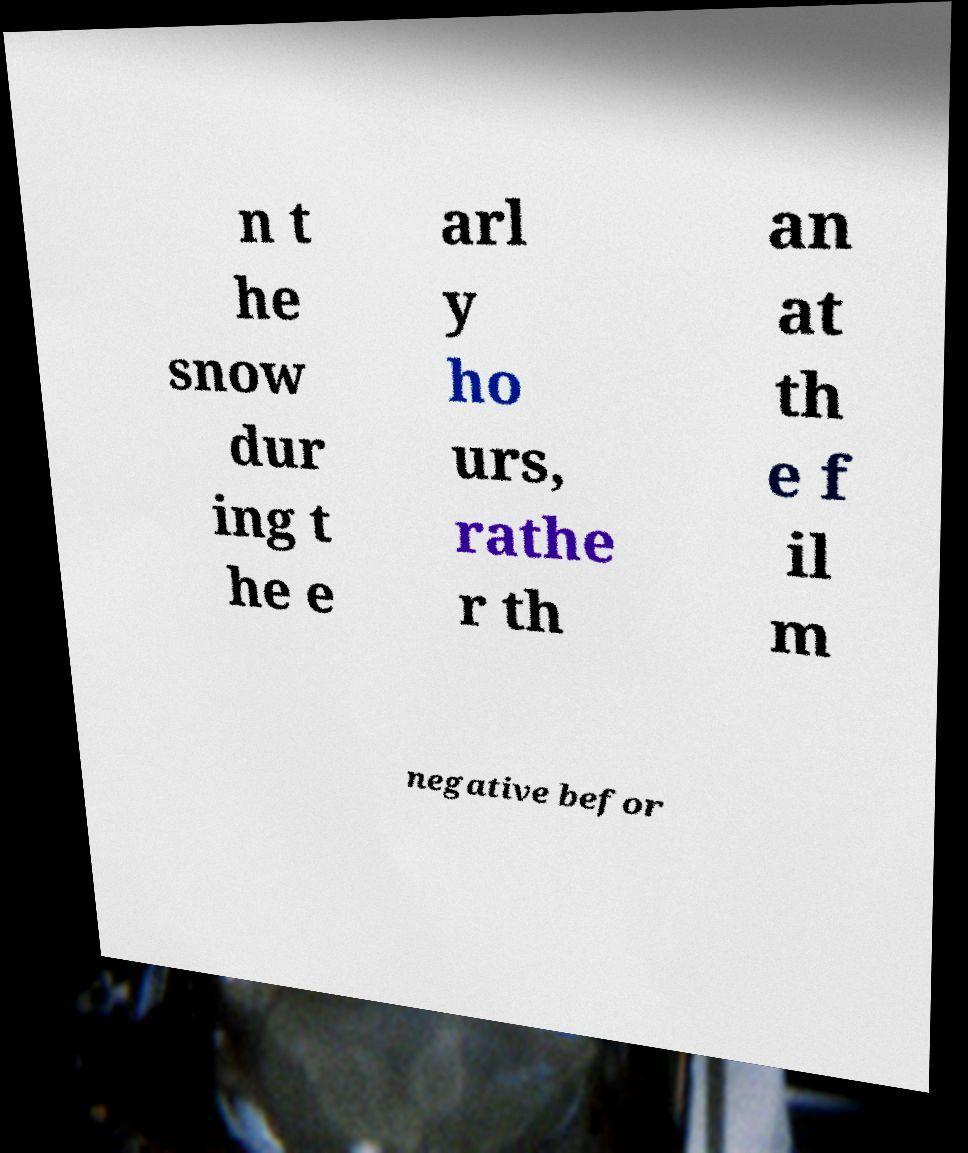Please read and relay the text visible in this image. What does it say? n t he snow dur ing t he e arl y ho urs, rathe r th an at th e f il m negative befor 